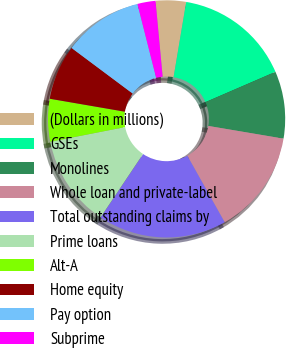Convert chart to OTSL. <chart><loc_0><loc_0><loc_500><loc_500><pie_chart><fcel>(Dollars in millions)<fcel>GSEs<fcel>Monolines<fcel>Whole loan and private-label<fcel>Total outstanding claims by<fcel>Prime loans<fcel>Alt-A<fcel>Home equity<fcel>Pay option<fcel>Subprime<nl><fcel>4.14%<fcel>15.86%<fcel>9.16%<fcel>14.19%<fcel>17.54%<fcel>12.51%<fcel>5.81%<fcel>7.49%<fcel>10.84%<fcel>2.46%<nl></chart> 